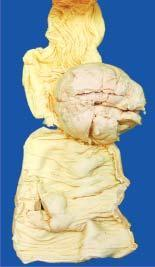s viral dna seen projecting into lumen while the covering mucosa is ulcerated?
Answer the question using a single word or phrase. No 